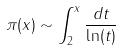<formula> <loc_0><loc_0><loc_500><loc_500>\pi ( x ) \sim \int _ { 2 } ^ { x } \frac { d t } { \ln ( t ) }</formula> 